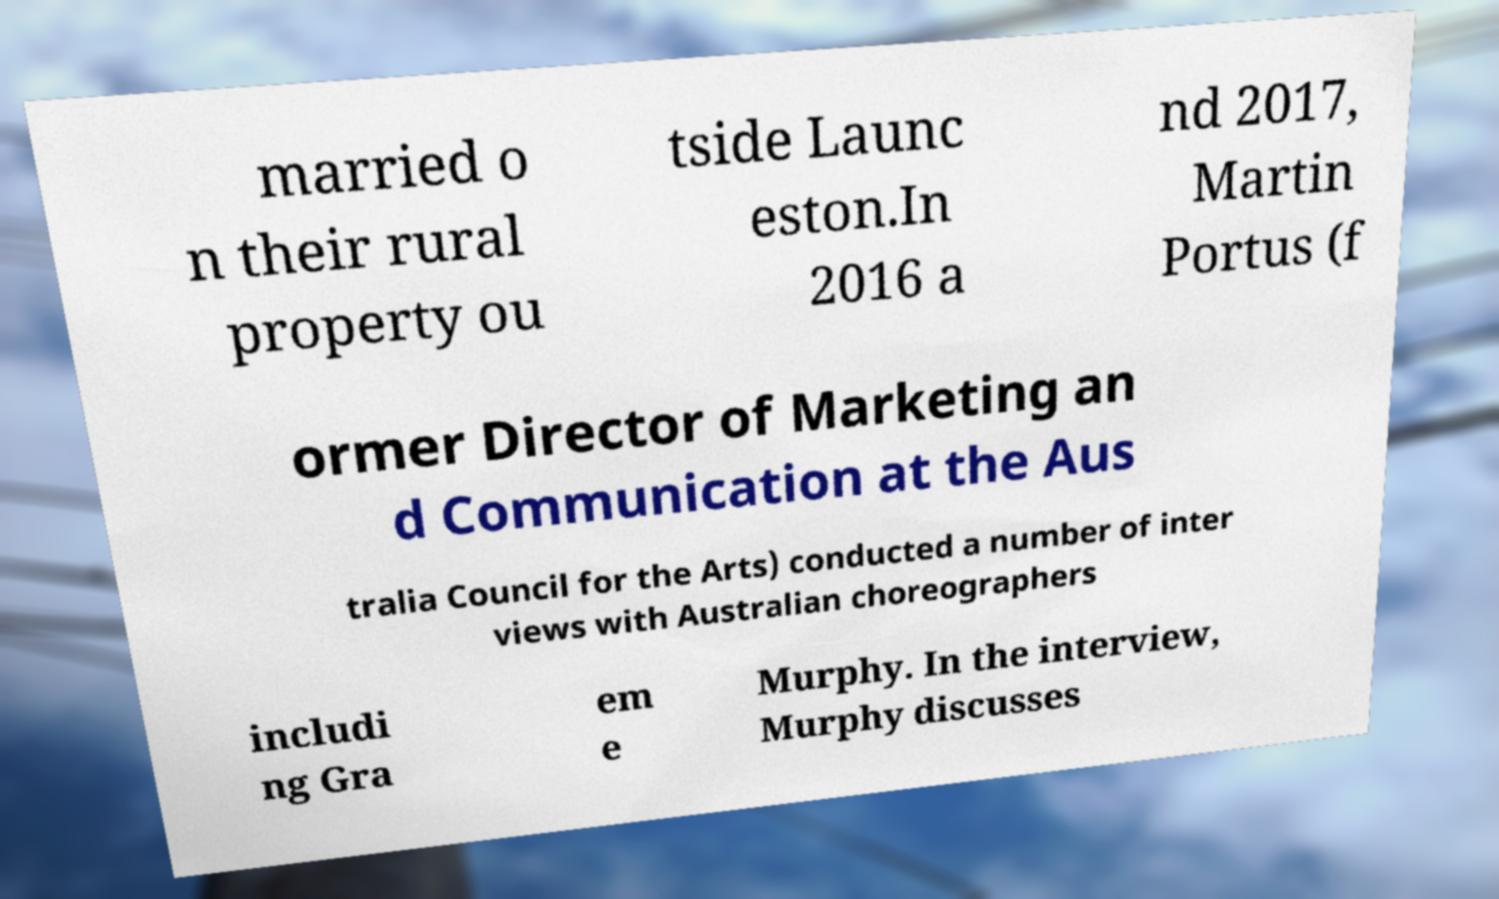What messages or text are displayed in this image? I need them in a readable, typed format. married o n their rural property ou tside Launc eston.In 2016 a nd 2017, Martin Portus (f ormer Director of Marketing an d Communication at the Aus tralia Council for the Arts) conducted a number of inter views with Australian choreographers includi ng Gra em e Murphy. In the interview, Murphy discusses 